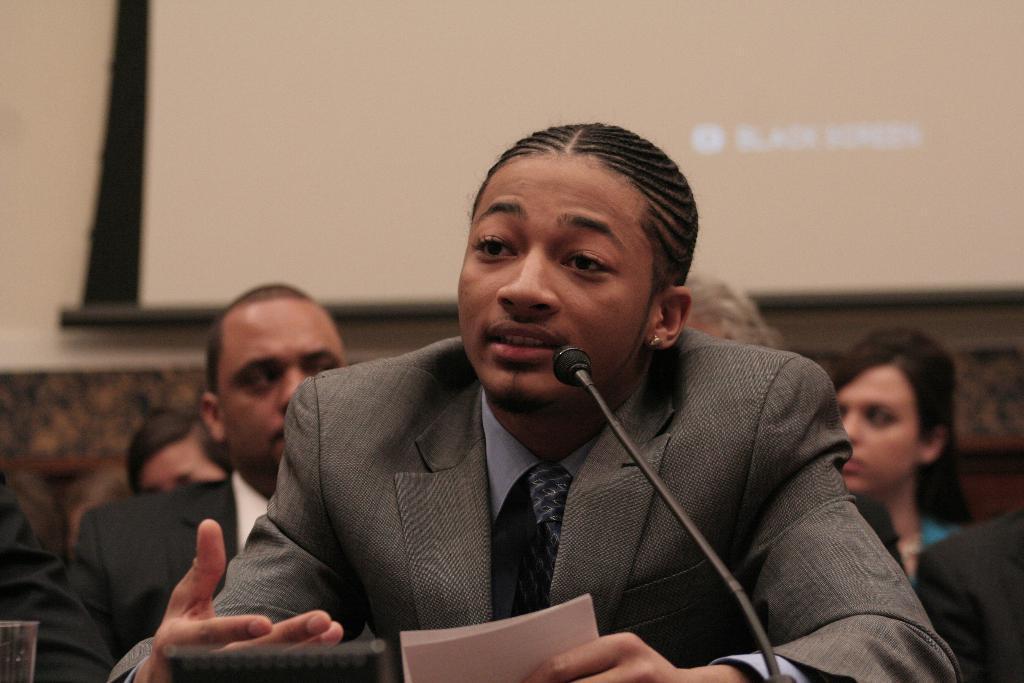In one or two sentences, can you explain what this image depicts? This picture might be taken inside the room. In this image, in the middle, we can see a man sitting on the chair in front of the microphone and he is also holding a paper in his hand. In the background, we can see group of people sitting on the chair, screen and a wall. On the left side corner, we can also see a glass. 